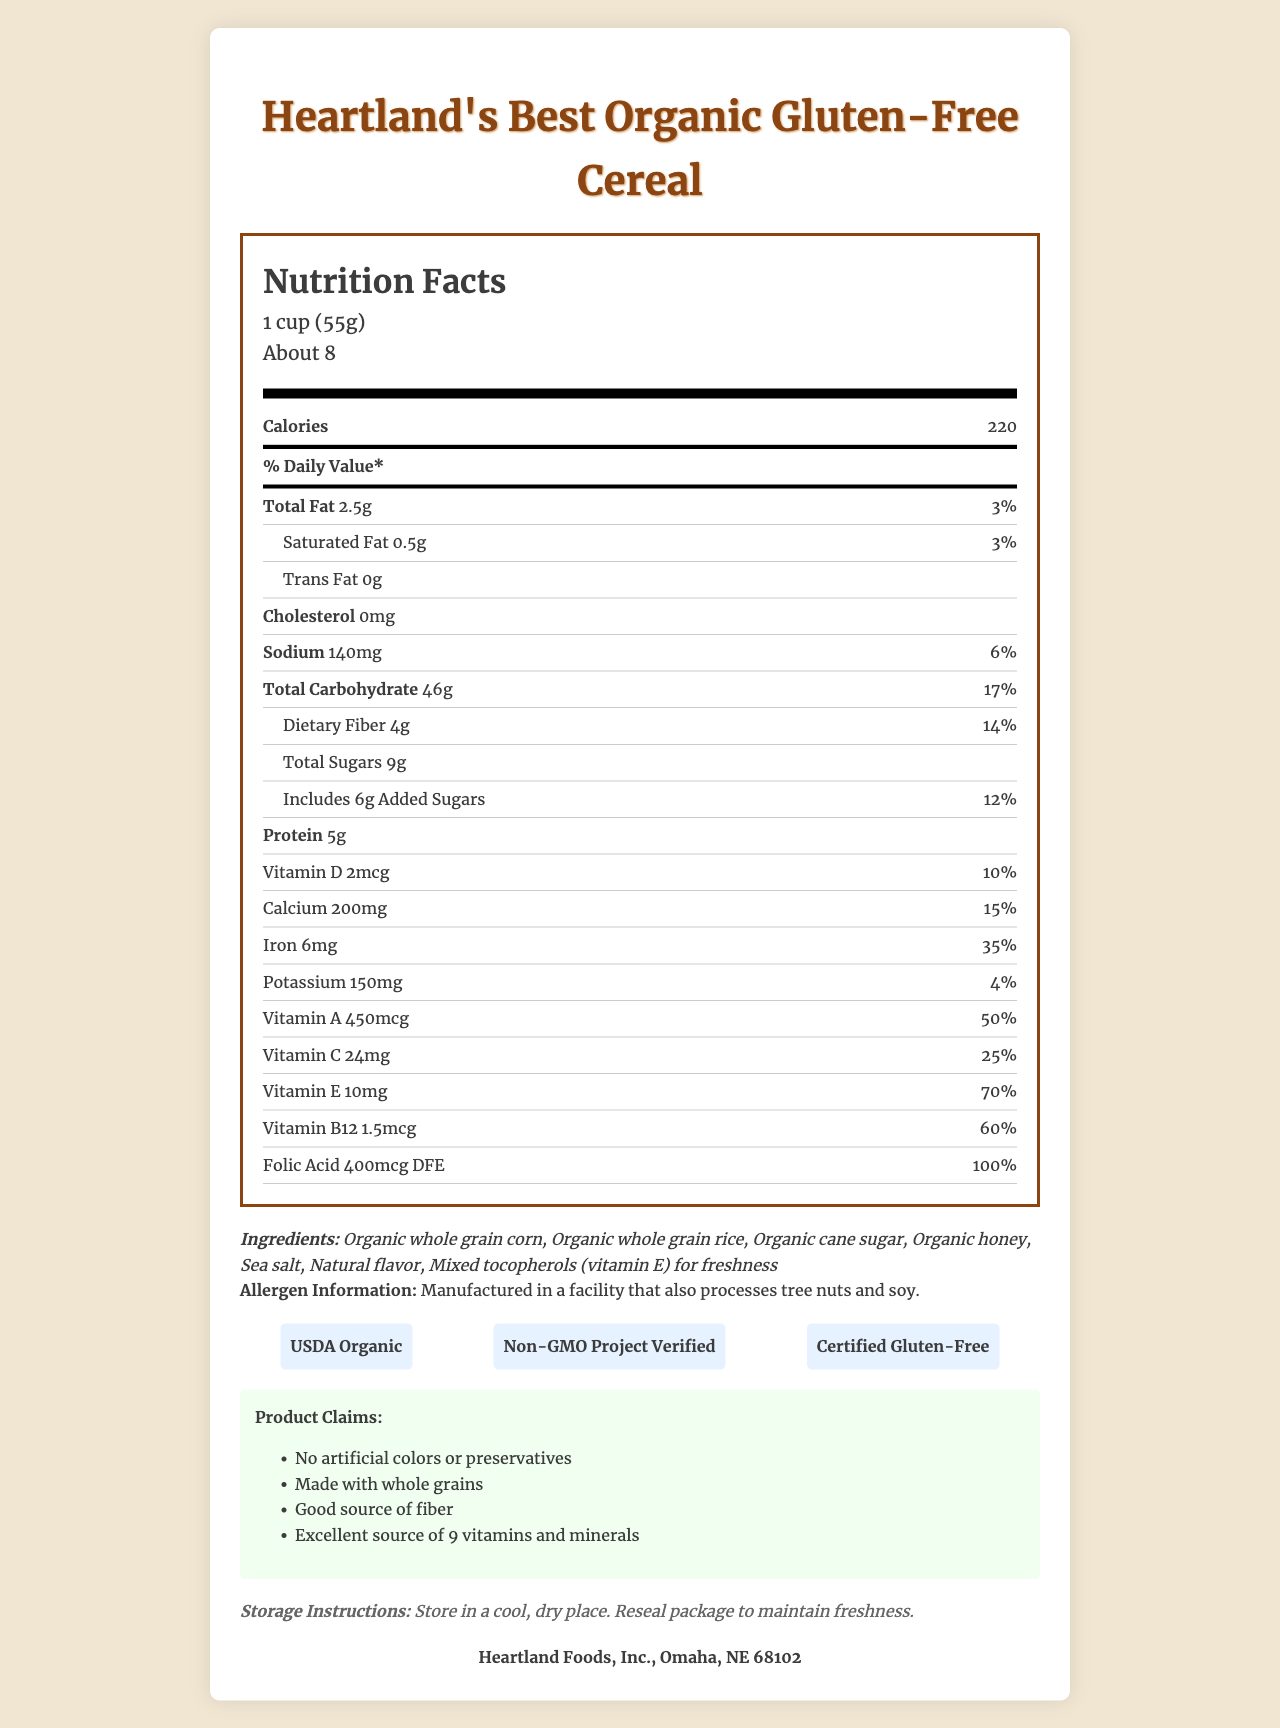what is the serving size of Heartland's Best Organic Gluten-Free Cereal? The serving size specified on the Nutrition Facts Label is 1 cup (55g).
Answer: 1 cup (55g) how many servings are there per container? The label states that there are about 8 servings per container.
Answer: About 8 how many calories are in one serving? The label lists the calorie content as 220 calories per serving.
Answer: 220 what is the amount of total fat in one serving? The total fat per serving is indicated as 2.5g on the Nutrition Facts Label.
Answer: 2.5g how much dietary fiber does the cereal contain per serving? It says 4g under the dietary fiber section of the label.
Answer: 4g how many grams of added sugars are included per serving? The label specifies that there are 6g of added sugars per serving.
Answer: 6g which vitamin has the highest daily value percentage per serving? A. Vitamin D B. Vitamin C C. Vitamin A D. Vitamin E Vitamin E has the highest daily value percentage at 70%.
Answer: D how much calcium is present in one serving? A. 150mg B. 200mg C. 250mg D. 300mg The label shows 200mg of calcium per serving.
Answer: B does the cereal contain trans fat? The label clearly states that the cereal contains 0g of trans fat.
Answer: No is Heartland's Best Organic Gluten-Free Cereal a good source of protein? The label states that each serving contains 5g of protein, which is relatively high.
Answer: Yes what are the main ingredients listed? The ingredient list includes these main components.
Answer: Organic whole grain corn, Organic whole grain rice, Organic cane sugar, Organic honey, Sea salt, Natural flavor, Mixed tocopherols (vitamin E) for freshness what certifications does this product have? The certifications are listed as USDA Organic, Non-GMO Project Verified, and Certified Gluten-Free.
Answer: USDA Organic, Non-GMO Project Verified, Certified Gluten-Free where is Heartland Foods, Inc. located? The manufacturer information at the bottom of the label indicates that it is based in Omaha, NE 68102.
Answer: Omaha, NE 68102 is the cereal free from artificial colors and preservatives? The product claims section states that it has no artificial colors or preservatives.
Answer: Yes what should you do to maintain freshness after opening? The storage instructions indicate to reseal the package to maintain freshness.
Answer: Reseal package describe the main idea of the Nutrition Facts Label for Heartland's Best Organic Gluten-Free Cereal. The detailed description of the entire label helps consumers understand the nutritional content and benefits of the cereal, along with how to store it properly.
Answer: The label for Heartland's Best Organic Gluten-Free Cereal provides detailed nutritional information including calorie count, fat, cholesterol, sodium, carbohydrate, fiber, sugar, and protein content per serving. It lists the amounts of various vitamins and minerals, along with ingredient details, allergen information, product certifications, claims, and storage instructions. It highlights that the cereal is organic, gluten-free, and enriched with vitamins and minerals. how much sodium does one serving contain? The label lists sodium content as 140mg per serving.
Answer: 140mg what is the daily value percentage of iron per serving? Iron has a daily value percentage of 35% according to the label.
Answer: 35% are there any claims about fiber content? The product claims state that it is a good source of fiber.
Answer: Yes which vitamin on the label does not have its daily value percentage mentioned? All vitamins listed on the label show their respective daily value percentages.
Answer: None does this cereal contain soy? The label only indicates that the product is manufactured in a facility that processes soy, but it does not confirm whether soy is in the cereal itself.
Answer: Cannot be determined 